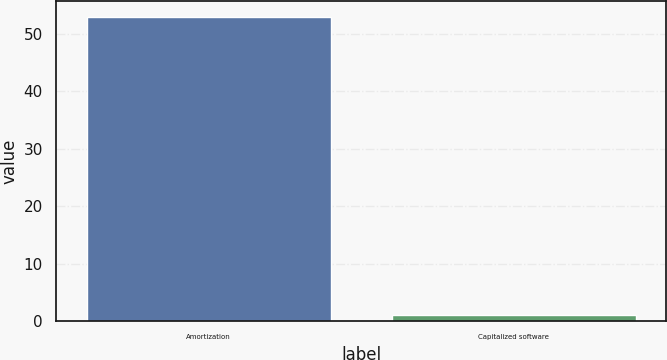Convert chart to OTSL. <chart><loc_0><loc_0><loc_500><loc_500><bar_chart><fcel>Amortization<fcel>Capitalized software<nl><fcel>53<fcel>1<nl></chart> 